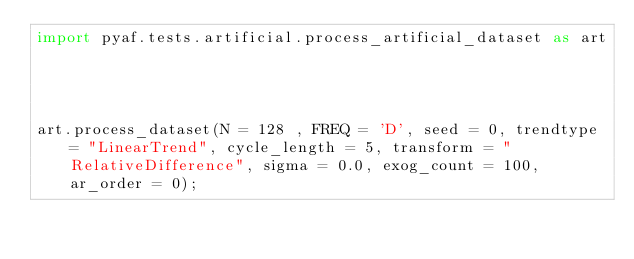<code> <loc_0><loc_0><loc_500><loc_500><_Python_>import pyaf.tests.artificial.process_artificial_dataset as art




art.process_dataset(N = 128 , FREQ = 'D', seed = 0, trendtype = "LinearTrend", cycle_length = 5, transform = "RelativeDifference", sigma = 0.0, exog_count = 100, ar_order = 0);</code> 